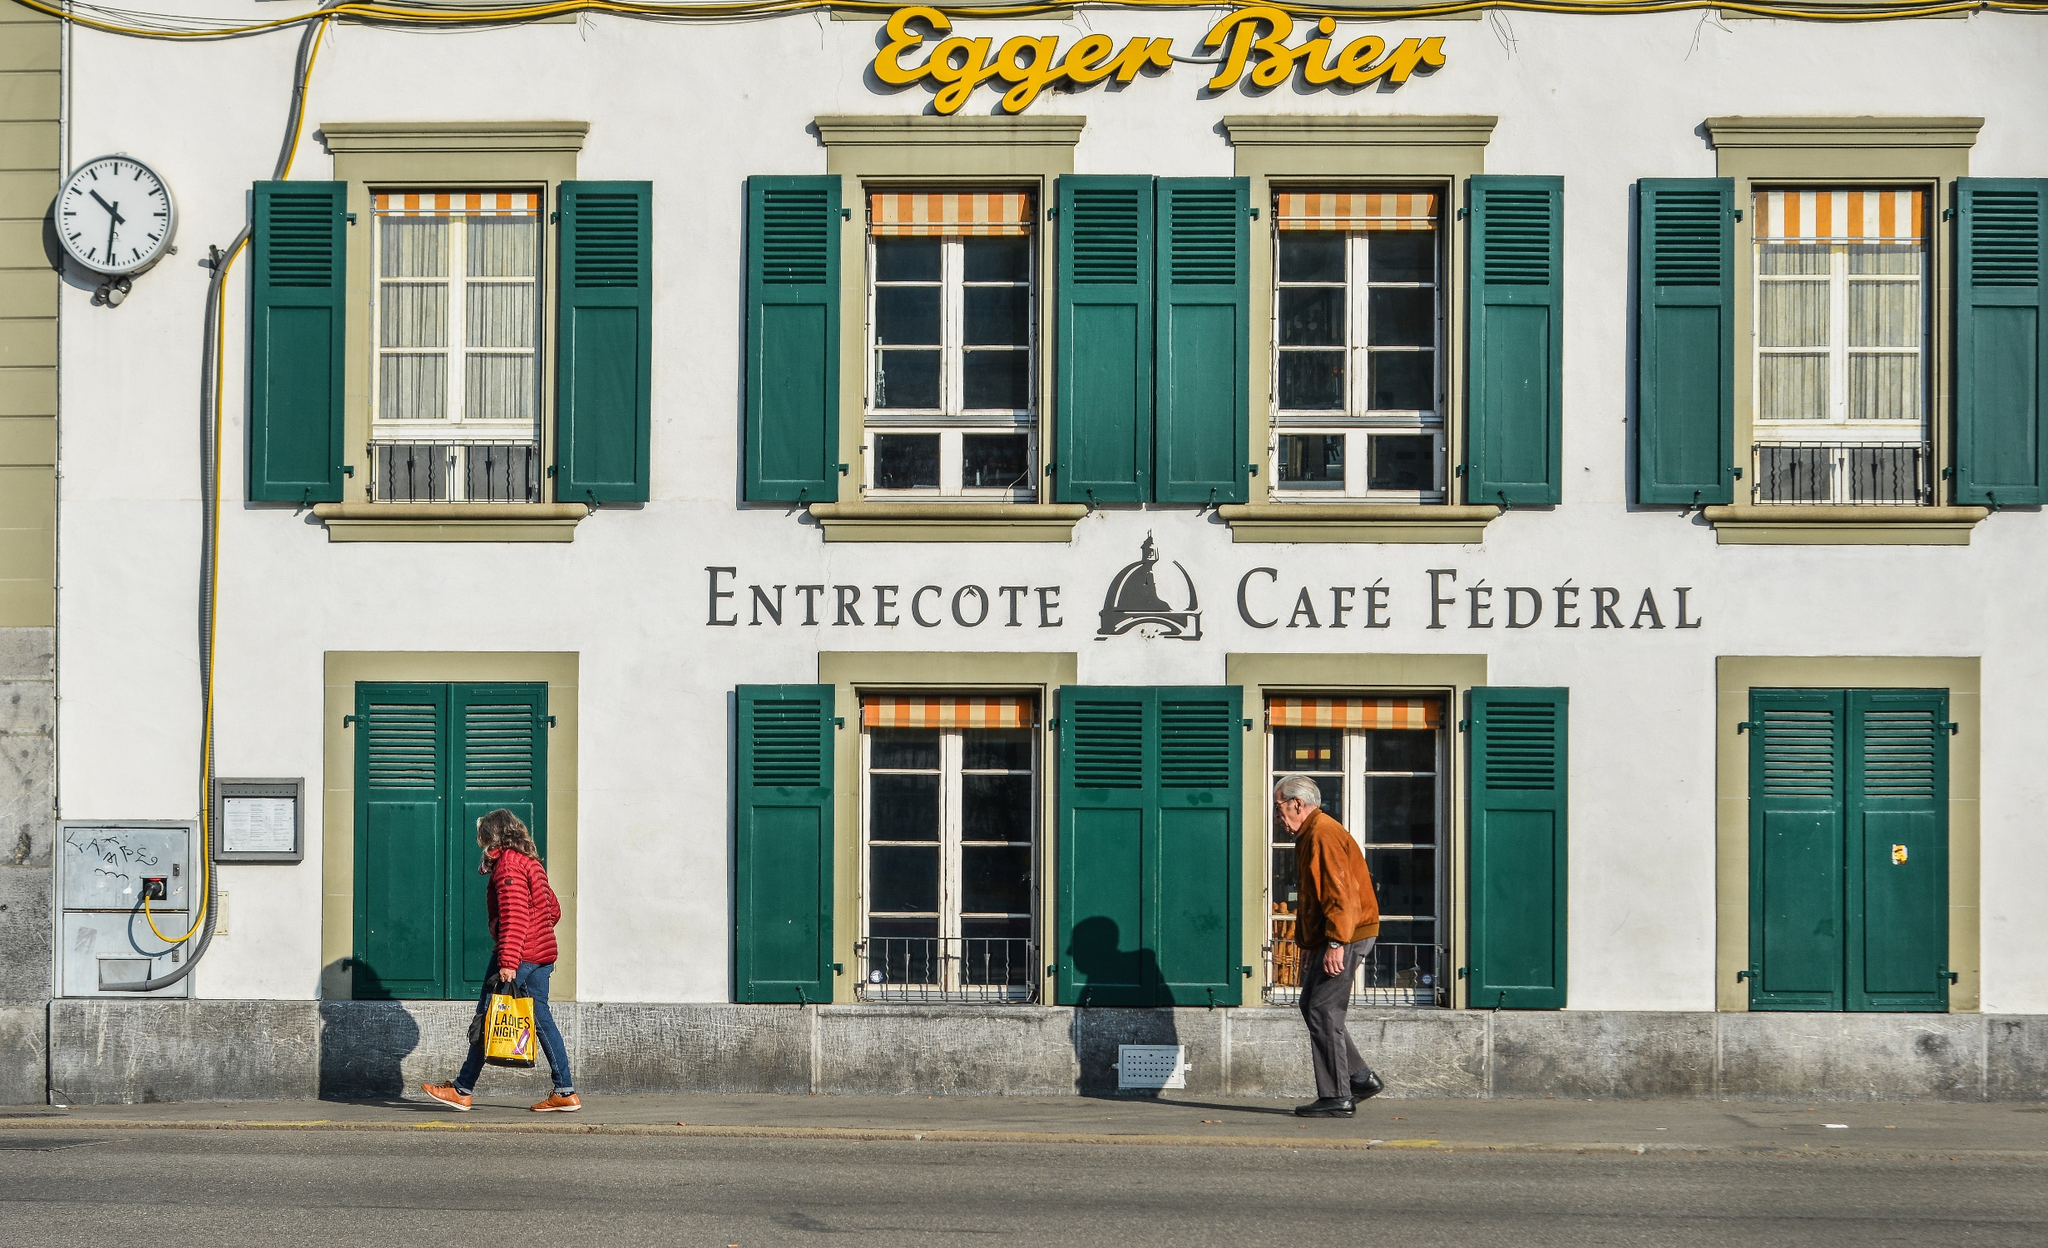Imagine a magical event taking place in this café. One enchanting evening, as twilight hues painted the sky, the 'Entrecote Café Fédéral' transformed into the setting for a wondrous spectacle. Twinkling fairy lights and lanterns adorned the facade, casting a warm golden glow as they blinked rhythmically in the gentle breeze. Inside, the tables were set with ethereal glassware that shimmered with a light of its own, and each seat was filled with guests dressed in an array of magical attire, from flowing robes to elegant gowns. At the stroke of 8 PM, the enchantment began. An unseen orchestra played a soulful melody, and the air was filled with the soft whisper of ancestral spirits sharing tales of old Switzerland. The clock on the wall began to chime, and with each note, the café seemed to expand, taking all inside on a journey through time. Past and present overlapped, and guests found themselves dancing with historical figures, drinking enchanting potions that told the story of the land, and engaging in conversations with authors of ancient Swiss lore. As the final note of the orchestra faded, the café returned to its original state, leaving the guests in awe of the magical event they'd just experienced, a moment engraved in their memories forever. 